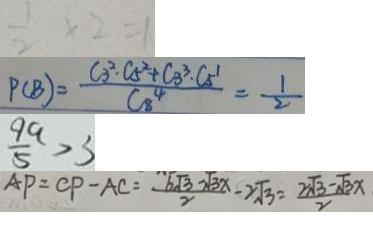<formula> <loc_0><loc_0><loc_500><loc_500>\frac { 1 } { 2 } \times 2 = 1 
 P ( B ) = \frac { C 3 ^ { 2 } \cdot C 5 ^ { 2 } + C _ { 3 } ^ { 3 } \cdot C _ { 5 } ^ { 1 } } { C _ { 8 } ^ { 4 } } = \frac { 1 } { 2 } 
 \frac { 9 a } { 5 } > 3 
 A P = C P - A C = \frac { 6 \sqrt { 3 } - \sqrt { 3 x } } { 2 } - 2 \sqrt { 3 } = \frac { 2 \sqrt { 3 } - \sqrt { 3 } x } { 2 }</formula> 